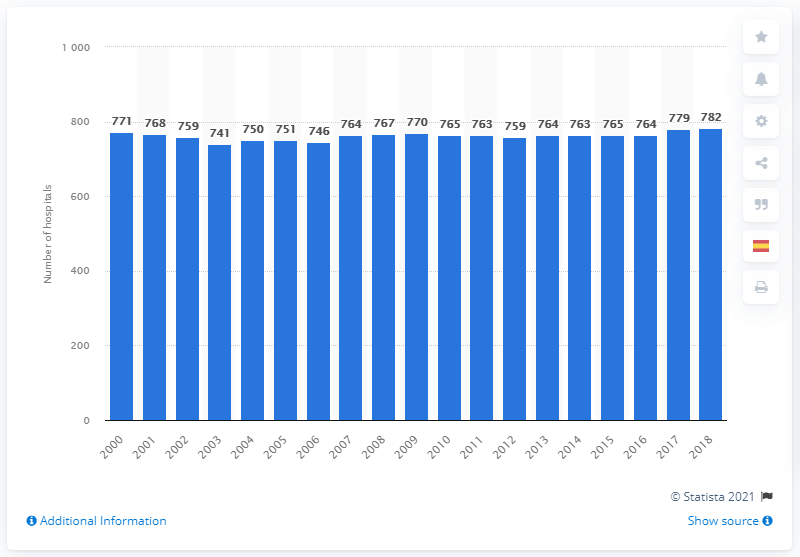Point out several critical features in this image. There were 782 hospitals in Spain in 2018, the highest number on record. 